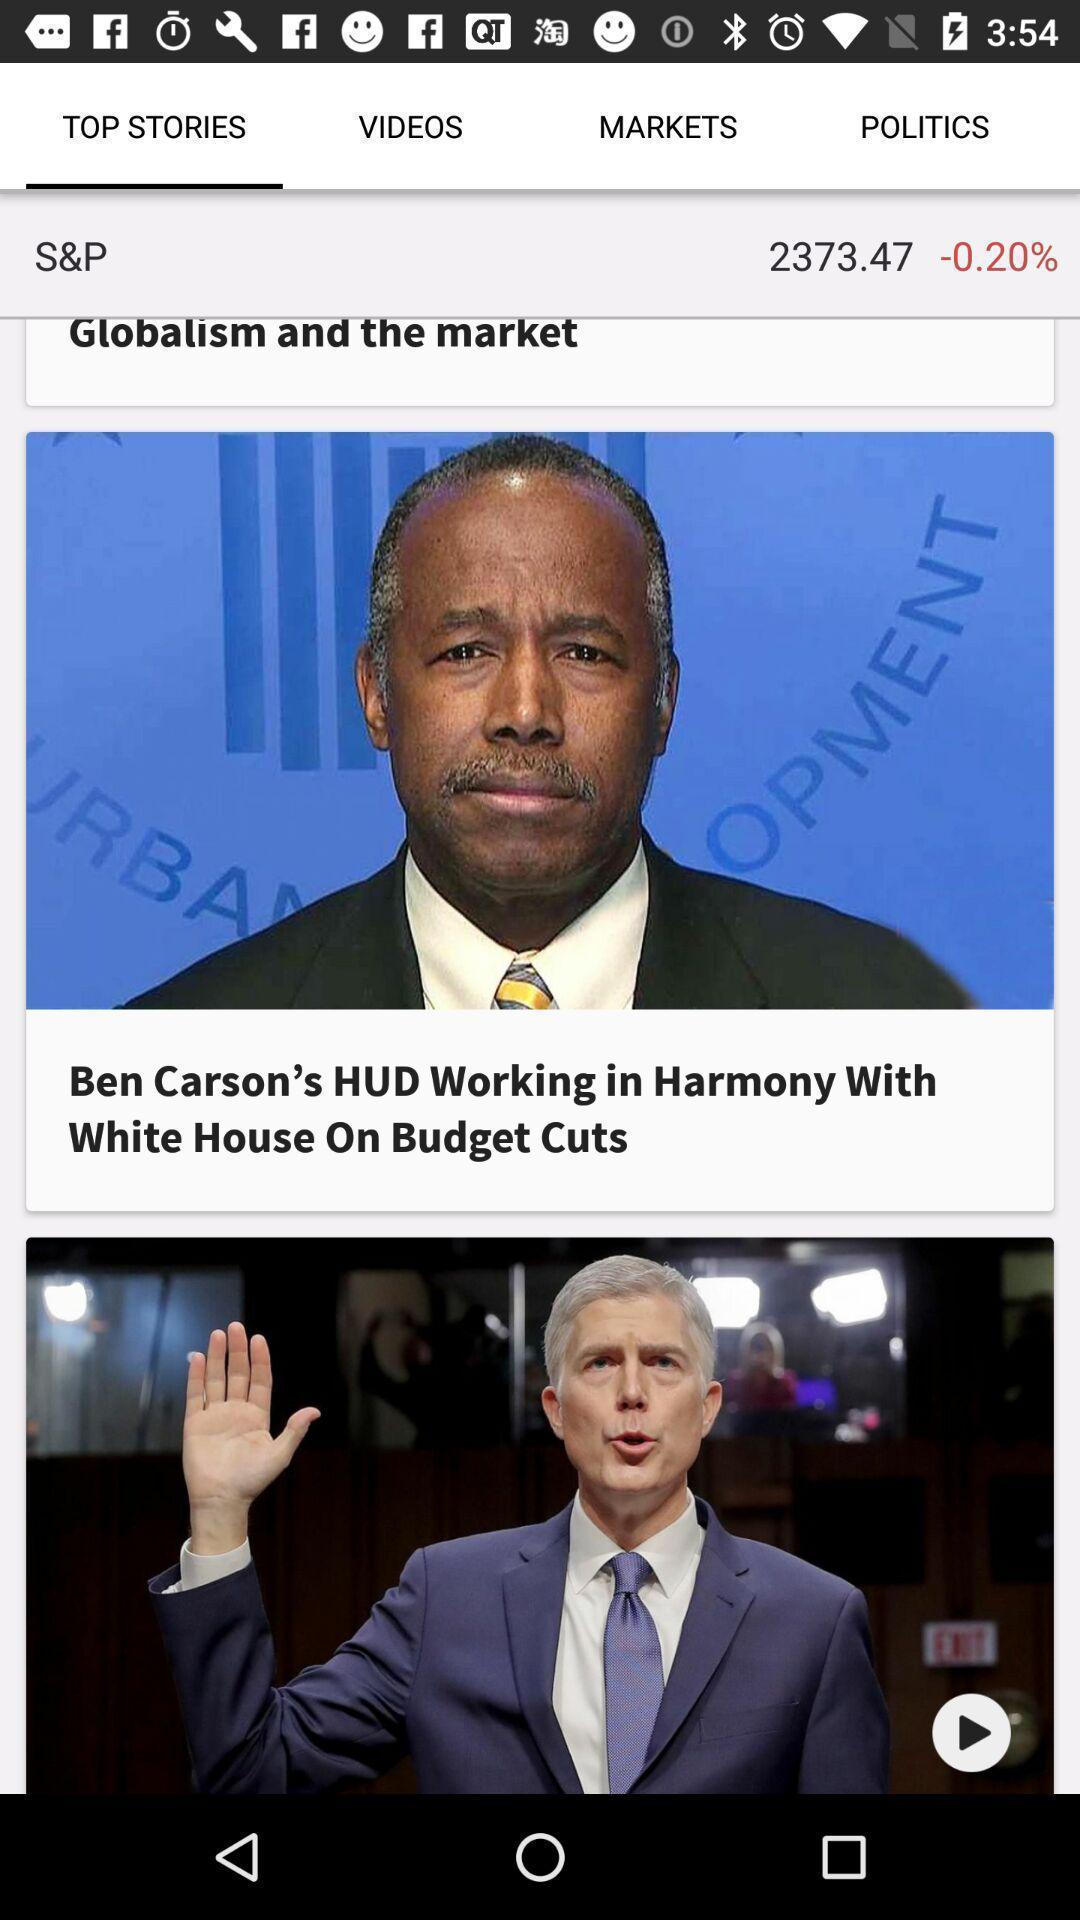Describe this image in words. Top stories in the news app. 